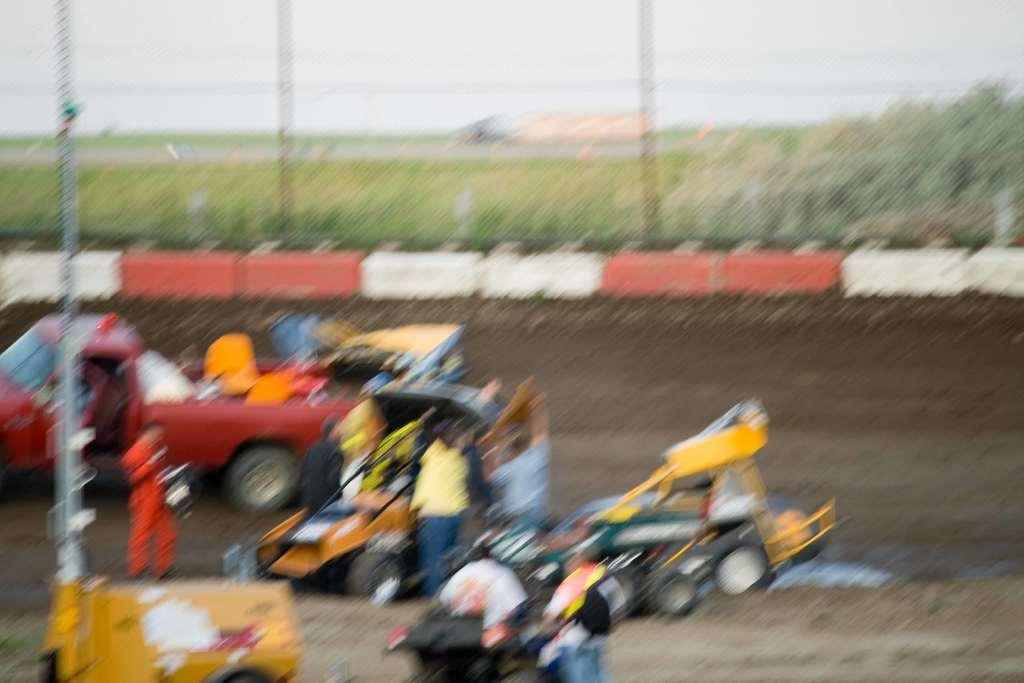What are the people in the image doing? The people in the image are standing on the ground. What else can be seen in the image besides the people? Motor vehicles and poles are present in the image. What type of natural elements can be seen in the image? Trees are visible in the image. What is visible in the background of the image? The sky is visible in the image. What type of lumber is being used to build the bird's nest in the image? There is no bird or nest present in the image, so it is not possible to determine what type of lumber might be used. 